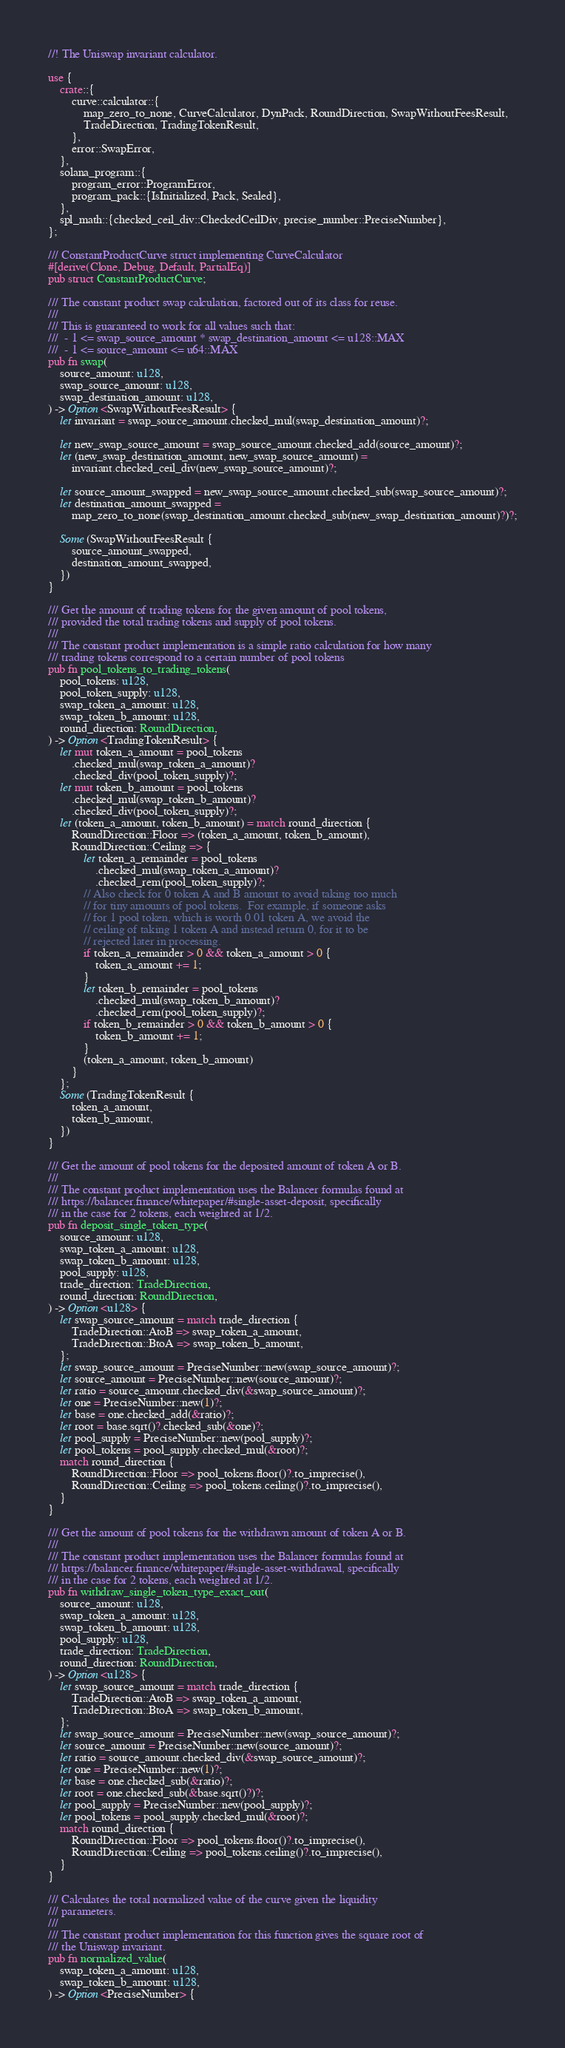Convert code to text. <code><loc_0><loc_0><loc_500><loc_500><_Rust_>//! The Uniswap invariant calculator.

use {
    crate::{
        curve::calculator::{
            map_zero_to_none, CurveCalculator, DynPack, RoundDirection, SwapWithoutFeesResult,
            TradeDirection, TradingTokenResult,
        },
        error::SwapError,
    },
    solana_program::{
        program_error::ProgramError,
        program_pack::{IsInitialized, Pack, Sealed},
    },
    spl_math::{checked_ceil_div::CheckedCeilDiv, precise_number::PreciseNumber},
};

/// ConstantProductCurve struct implementing CurveCalculator
#[derive(Clone, Debug, Default, PartialEq)]
pub struct ConstantProductCurve;

/// The constant product swap calculation, factored out of its class for reuse.
///
/// This is guaranteed to work for all values such that:
///  - 1 <= swap_source_amount * swap_destination_amount <= u128::MAX
///  - 1 <= source_amount <= u64::MAX
pub fn swap(
    source_amount: u128,
    swap_source_amount: u128,
    swap_destination_amount: u128,
) -> Option<SwapWithoutFeesResult> {
    let invariant = swap_source_amount.checked_mul(swap_destination_amount)?;

    let new_swap_source_amount = swap_source_amount.checked_add(source_amount)?;
    let (new_swap_destination_amount, new_swap_source_amount) =
        invariant.checked_ceil_div(new_swap_source_amount)?;

    let source_amount_swapped = new_swap_source_amount.checked_sub(swap_source_amount)?;
    let destination_amount_swapped =
        map_zero_to_none(swap_destination_amount.checked_sub(new_swap_destination_amount)?)?;

    Some(SwapWithoutFeesResult {
        source_amount_swapped,
        destination_amount_swapped,
    })
}

/// Get the amount of trading tokens for the given amount of pool tokens,
/// provided the total trading tokens and supply of pool tokens.
///
/// The constant product implementation is a simple ratio calculation for how many
/// trading tokens correspond to a certain number of pool tokens
pub fn pool_tokens_to_trading_tokens(
    pool_tokens: u128,
    pool_token_supply: u128,
    swap_token_a_amount: u128,
    swap_token_b_amount: u128,
    round_direction: RoundDirection,
) -> Option<TradingTokenResult> {
    let mut token_a_amount = pool_tokens
        .checked_mul(swap_token_a_amount)?
        .checked_div(pool_token_supply)?;
    let mut token_b_amount = pool_tokens
        .checked_mul(swap_token_b_amount)?
        .checked_div(pool_token_supply)?;
    let (token_a_amount, token_b_amount) = match round_direction {
        RoundDirection::Floor => (token_a_amount, token_b_amount),
        RoundDirection::Ceiling => {
            let token_a_remainder = pool_tokens
                .checked_mul(swap_token_a_amount)?
                .checked_rem(pool_token_supply)?;
            // Also check for 0 token A and B amount to avoid taking too much
            // for tiny amounts of pool tokens.  For example, if someone asks
            // for 1 pool token, which is worth 0.01 token A, we avoid the
            // ceiling of taking 1 token A and instead return 0, for it to be
            // rejected later in processing.
            if token_a_remainder > 0 && token_a_amount > 0 {
                token_a_amount += 1;
            }
            let token_b_remainder = pool_tokens
                .checked_mul(swap_token_b_amount)?
                .checked_rem(pool_token_supply)?;
            if token_b_remainder > 0 && token_b_amount > 0 {
                token_b_amount += 1;
            }
            (token_a_amount, token_b_amount)
        }
    };
    Some(TradingTokenResult {
        token_a_amount,
        token_b_amount,
    })
}

/// Get the amount of pool tokens for the deposited amount of token A or B.
///
/// The constant product implementation uses the Balancer formulas found at
/// https://balancer.finance/whitepaper/#single-asset-deposit, specifically
/// in the case for 2 tokens, each weighted at 1/2.
pub fn deposit_single_token_type(
    source_amount: u128,
    swap_token_a_amount: u128,
    swap_token_b_amount: u128,
    pool_supply: u128,
    trade_direction: TradeDirection,
    round_direction: RoundDirection,
) -> Option<u128> {
    let swap_source_amount = match trade_direction {
        TradeDirection::AtoB => swap_token_a_amount,
        TradeDirection::BtoA => swap_token_b_amount,
    };
    let swap_source_amount = PreciseNumber::new(swap_source_amount)?;
    let source_amount = PreciseNumber::new(source_amount)?;
    let ratio = source_amount.checked_div(&swap_source_amount)?;
    let one = PreciseNumber::new(1)?;
    let base = one.checked_add(&ratio)?;
    let root = base.sqrt()?.checked_sub(&one)?;
    let pool_supply = PreciseNumber::new(pool_supply)?;
    let pool_tokens = pool_supply.checked_mul(&root)?;
    match round_direction {
        RoundDirection::Floor => pool_tokens.floor()?.to_imprecise(),
        RoundDirection::Ceiling => pool_tokens.ceiling()?.to_imprecise(),
    }
}

/// Get the amount of pool tokens for the withdrawn amount of token A or B.
///
/// The constant product implementation uses the Balancer formulas found at
/// https://balancer.finance/whitepaper/#single-asset-withdrawal, specifically
/// in the case for 2 tokens, each weighted at 1/2.
pub fn withdraw_single_token_type_exact_out(
    source_amount: u128,
    swap_token_a_amount: u128,
    swap_token_b_amount: u128,
    pool_supply: u128,
    trade_direction: TradeDirection,
    round_direction: RoundDirection,
) -> Option<u128> {
    let swap_source_amount = match trade_direction {
        TradeDirection::AtoB => swap_token_a_amount,
        TradeDirection::BtoA => swap_token_b_amount,
    };
    let swap_source_amount = PreciseNumber::new(swap_source_amount)?;
    let source_amount = PreciseNumber::new(source_amount)?;
    let ratio = source_amount.checked_div(&swap_source_amount)?;
    let one = PreciseNumber::new(1)?;
    let base = one.checked_sub(&ratio)?;
    let root = one.checked_sub(&base.sqrt()?)?;
    let pool_supply = PreciseNumber::new(pool_supply)?;
    let pool_tokens = pool_supply.checked_mul(&root)?;
    match round_direction {
        RoundDirection::Floor => pool_tokens.floor()?.to_imprecise(),
        RoundDirection::Ceiling => pool_tokens.ceiling()?.to_imprecise(),
    }
}

/// Calculates the total normalized value of the curve given the liquidity
/// parameters.
///
/// The constant product implementation for this function gives the square root of
/// the Uniswap invariant.
pub fn normalized_value(
    swap_token_a_amount: u128,
    swap_token_b_amount: u128,
) -> Option<PreciseNumber> {</code> 